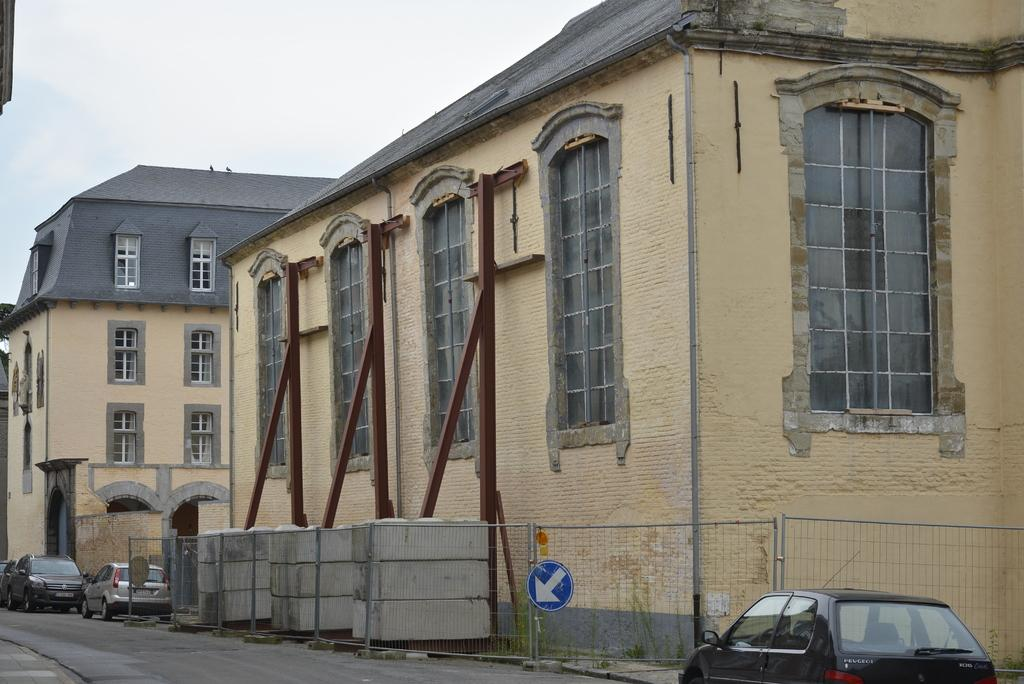What type of structures can be seen in the image? There are buildings in the image. What feature is common to many of the buildings? There are windows in the buildings. What type of transportation is visible in the image? There are vehicles in the image. What type of barrier is present in the image? There is net fencing in the image. What type of information might be conveyed by the signboards in the image? The signboards in the image might convey information about directions, advertisements, or warnings. What type of support structures are present in the image? There are iron poles in the image. What is the color of the sky in the image? The sky appears to be white in color. Where is the tub located in the image? There is no tub present in the image. What type of bird is visible in the image? There is no bird, including a turkey, present in the image. 